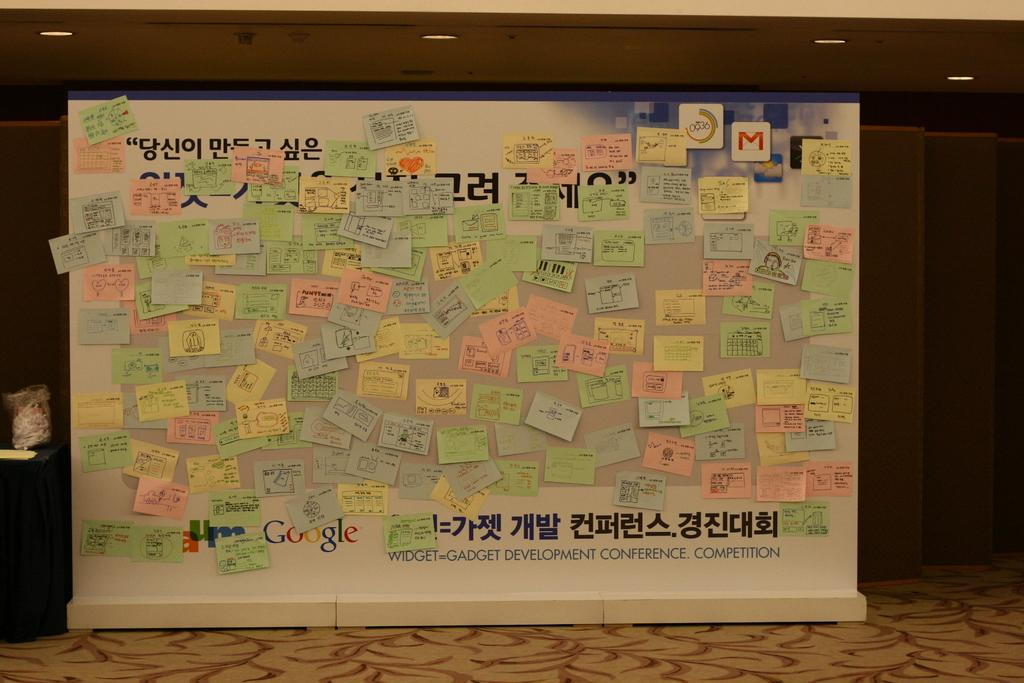<image>
Render a clear and concise summary of the photo. A bulletin board from a gadget development conference. 